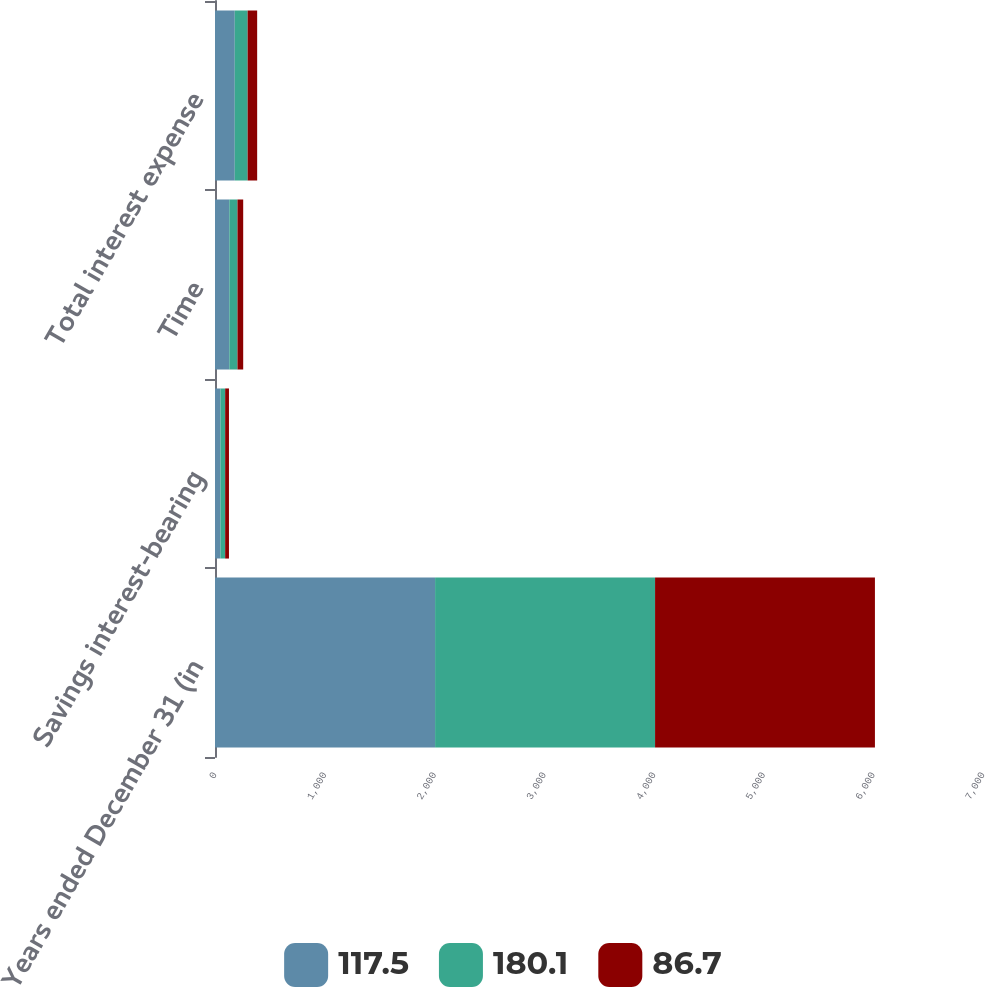Convert chart to OTSL. <chart><loc_0><loc_0><loc_500><loc_500><stacked_bar_chart><ecel><fcel>Years ended December 31 (in<fcel>Savings interest-bearing<fcel>Time<fcel>Total interest expense<nl><fcel>117.5<fcel>2006<fcel>49.6<fcel>130.5<fcel>180.1<nl><fcel>180.1<fcel>2005<fcel>43<fcel>74.5<fcel>117.5<nl><fcel>86.7<fcel>2004<fcel>34.7<fcel>52<fcel>86.7<nl></chart> 